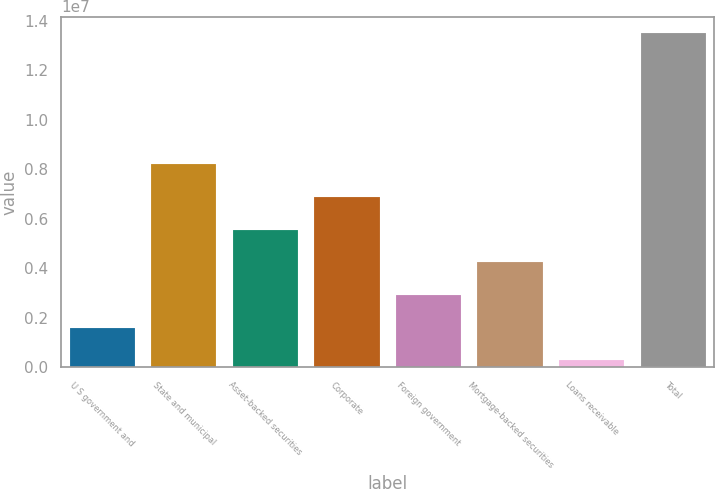Convert chart. <chart><loc_0><loc_0><loc_500><loc_500><bar_chart><fcel>U S government and<fcel>State and municipal<fcel>Asset-backed securities<fcel>Corporate<fcel>Foreign government<fcel>Mortgage-backed securities<fcel>Loans receivable<fcel>Total<nl><fcel>1.59839e+06<fcel>8.21163e+06<fcel>5.56634e+06<fcel>6.88899e+06<fcel>2.92104e+06<fcel>4.24369e+06<fcel>275747<fcel>1.35022e+07<nl></chart> 